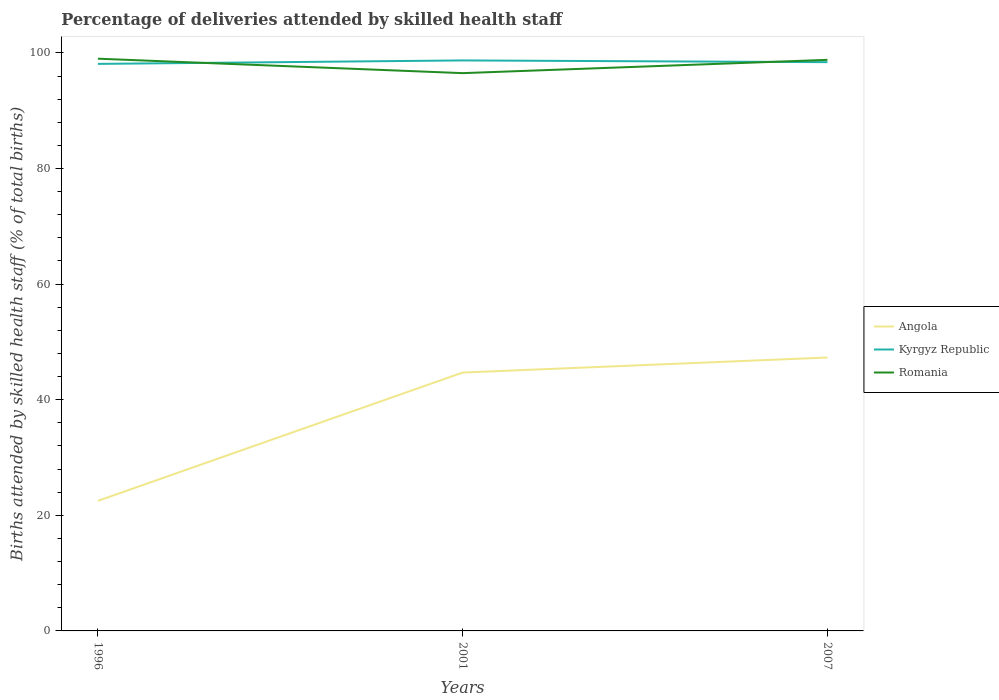Does the line corresponding to Romania intersect with the line corresponding to Kyrgyz Republic?
Your answer should be very brief. Yes. Across all years, what is the maximum percentage of births attended by skilled health staff in Kyrgyz Republic?
Make the answer very short. 98.1. In which year was the percentage of births attended by skilled health staff in Angola maximum?
Make the answer very short. 1996. What is the total percentage of births attended by skilled health staff in Kyrgyz Republic in the graph?
Your answer should be compact. 0.3. What is the difference between the highest and the second highest percentage of births attended by skilled health staff in Kyrgyz Republic?
Keep it short and to the point. 0.6. What is the difference between the highest and the lowest percentage of births attended by skilled health staff in Kyrgyz Republic?
Your answer should be compact. 1. Is the percentage of births attended by skilled health staff in Angola strictly greater than the percentage of births attended by skilled health staff in Kyrgyz Republic over the years?
Offer a very short reply. Yes. How many years are there in the graph?
Provide a succinct answer. 3. What is the difference between two consecutive major ticks on the Y-axis?
Offer a terse response. 20. Are the values on the major ticks of Y-axis written in scientific E-notation?
Keep it short and to the point. No. How many legend labels are there?
Make the answer very short. 3. How are the legend labels stacked?
Your answer should be compact. Vertical. What is the title of the graph?
Make the answer very short. Percentage of deliveries attended by skilled health staff. What is the label or title of the X-axis?
Make the answer very short. Years. What is the label or title of the Y-axis?
Keep it short and to the point. Births attended by skilled health staff (% of total births). What is the Births attended by skilled health staff (% of total births) in Angola in 1996?
Offer a very short reply. 22.5. What is the Births attended by skilled health staff (% of total births) in Kyrgyz Republic in 1996?
Offer a very short reply. 98.1. What is the Births attended by skilled health staff (% of total births) of Romania in 1996?
Your answer should be compact. 99. What is the Births attended by skilled health staff (% of total births) in Angola in 2001?
Keep it short and to the point. 44.7. What is the Births attended by skilled health staff (% of total births) of Kyrgyz Republic in 2001?
Your response must be concise. 98.7. What is the Births attended by skilled health staff (% of total births) of Romania in 2001?
Your answer should be very brief. 96.5. What is the Births attended by skilled health staff (% of total births) in Angola in 2007?
Ensure brevity in your answer.  47.3. What is the Births attended by skilled health staff (% of total births) in Kyrgyz Republic in 2007?
Ensure brevity in your answer.  98.4. What is the Births attended by skilled health staff (% of total births) in Romania in 2007?
Your answer should be compact. 98.8. Across all years, what is the maximum Births attended by skilled health staff (% of total births) of Angola?
Offer a terse response. 47.3. Across all years, what is the maximum Births attended by skilled health staff (% of total births) in Kyrgyz Republic?
Provide a succinct answer. 98.7. Across all years, what is the minimum Births attended by skilled health staff (% of total births) of Kyrgyz Republic?
Give a very brief answer. 98.1. Across all years, what is the minimum Births attended by skilled health staff (% of total births) of Romania?
Ensure brevity in your answer.  96.5. What is the total Births attended by skilled health staff (% of total births) of Angola in the graph?
Your answer should be compact. 114.5. What is the total Births attended by skilled health staff (% of total births) in Kyrgyz Republic in the graph?
Your response must be concise. 295.2. What is the total Births attended by skilled health staff (% of total births) in Romania in the graph?
Offer a very short reply. 294.3. What is the difference between the Births attended by skilled health staff (% of total births) of Angola in 1996 and that in 2001?
Keep it short and to the point. -22.2. What is the difference between the Births attended by skilled health staff (% of total births) in Angola in 1996 and that in 2007?
Keep it short and to the point. -24.8. What is the difference between the Births attended by skilled health staff (% of total births) in Angola in 1996 and the Births attended by skilled health staff (% of total births) in Kyrgyz Republic in 2001?
Offer a terse response. -76.2. What is the difference between the Births attended by skilled health staff (% of total births) of Angola in 1996 and the Births attended by skilled health staff (% of total births) of Romania in 2001?
Make the answer very short. -74. What is the difference between the Births attended by skilled health staff (% of total births) of Angola in 1996 and the Births attended by skilled health staff (% of total births) of Kyrgyz Republic in 2007?
Give a very brief answer. -75.9. What is the difference between the Births attended by skilled health staff (% of total births) of Angola in 1996 and the Births attended by skilled health staff (% of total births) of Romania in 2007?
Provide a succinct answer. -76.3. What is the difference between the Births attended by skilled health staff (% of total births) in Angola in 2001 and the Births attended by skilled health staff (% of total births) in Kyrgyz Republic in 2007?
Make the answer very short. -53.7. What is the difference between the Births attended by skilled health staff (% of total births) of Angola in 2001 and the Births attended by skilled health staff (% of total births) of Romania in 2007?
Your answer should be compact. -54.1. What is the difference between the Births attended by skilled health staff (% of total births) of Kyrgyz Republic in 2001 and the Births attended by skilled health staff (% of total births) of Romania in 2007?
Offer a terse response. -0.1. What is the average Births attended by skilled health staff (% of total births) of Angola per year?
Provide a short and direct response. 38.17. What is the average Births attended by skilled health staff (% of total births) in Kyrgyz Republic per year?
Make the answer very short. 98.4. What is the average Births attended by skilled health staff (% of total births) in Romania per year?
Provide a succinct answer. 98.1. In the year 1996, what is the difference between the Births attended by skilled health staff (% of total births) in Angola and Births attended by skilled health staff (% of total births) in Kyrgyz Republic?
Provide a short and direct response. -75.6. In the year 1996, what is the difference between the Births attended by skilled health staff (% of total births) in Angola and Births attended by skilled health staff (% of total births) in Romania?
Offer a very short reply. -76.5. In the year 1996, what is the difference between the Births attended by skilled health staff (% of total births) in Kyrgyz Republic and Births attended by skilled health staff (% of total births) in Romania?
Your answer should be very brief. -0.9. In the year 2001, what is the difference between the Births attended by skilled health staff (% of total births) of Angola and Births attended by skilled health staff (% of total births) of Kyrgyz Republic?
Your answer should be compact. -54. In the year 2001, what is the difference between the Births attended by skilled health staff (% of total births) of Angola and Births attended by skilled health staff (% of total births) of Romania?
Provide a short and direct response. -51.8. In the year 2007, what is the difference between the Births attended by skilled health staff (% of total births) of Angola and Births attended by skilled health staff (% of total births) of Kyrgyz Republic?
Provide a short and direct response. -51.1. In the year 2007, what is the difference between the Births attended by skilled health staff (% of total births) of Angola and Births attended by skilled health staff (% of total births) of Romania?
Ensure brevity in your answer.  -51.5. In the year 2007, what is the difference between the Births attended by skilled health staff (% of total births) in Kyrgyz Republic and Births attended by skilled health staff (% of total births) in Romania?
Your response must be concise. -0.4. What is the ratio of the Births attended by skilled health staff (% of total births) in Angola in 1996 to that in 2001?
Provide a short and direct response. 0.5. What is the ratio of the Births attended by skilled health staff (% of total births) of Kyrgyz Republic in 1996 to that in 2001?
Your response must be concise. 0.99. What is the ratio of the Births attended by skilled health staff (% of total births) of Romania in 1996 to that in 2001?
Offer a very short reply. 1.03. What is the ratio of the Births attended by skilled health staff (% of total births) in Angola in 1996 to that in 2007?
Keep it short and to the point. 0.48. What is the ratio of the Births attended by skilled health staff (% of total births) in Kyrgyz Republic in 1996 to that in 2007?
Provide a short and direct response. 1. What is the ratio of the Births attended by skilled health staff (% of total births) in Angola in 2001 to that in 2007?
Make the answer very short. 0.94. What is the ratio of the Births attended by skilled health staff (% of total births) in Romania in 2001 to that in 2007?
Ensure brevity in your answer.  0.98. What is the difference between the highest and the second highest Births attended by skilled health staff (% of total births) in Kyrgyz Republic?
Make the answer very short. 0.3. What is the difference between the highest and the lowest Births attended by skilled health staff (% of total births) in Angola?
Provide a succinct answer. 24.8. What is the difference between the highest and the lowest Births attended by skilled health staff (% of total births) in Kyrgyz Republic?
Keep it short and to the point. 0.6. What is the difference between the highest and the lowest Births attended by skilled health staff (% of total births) in Romania?
Make the answer very short. 2.5. 